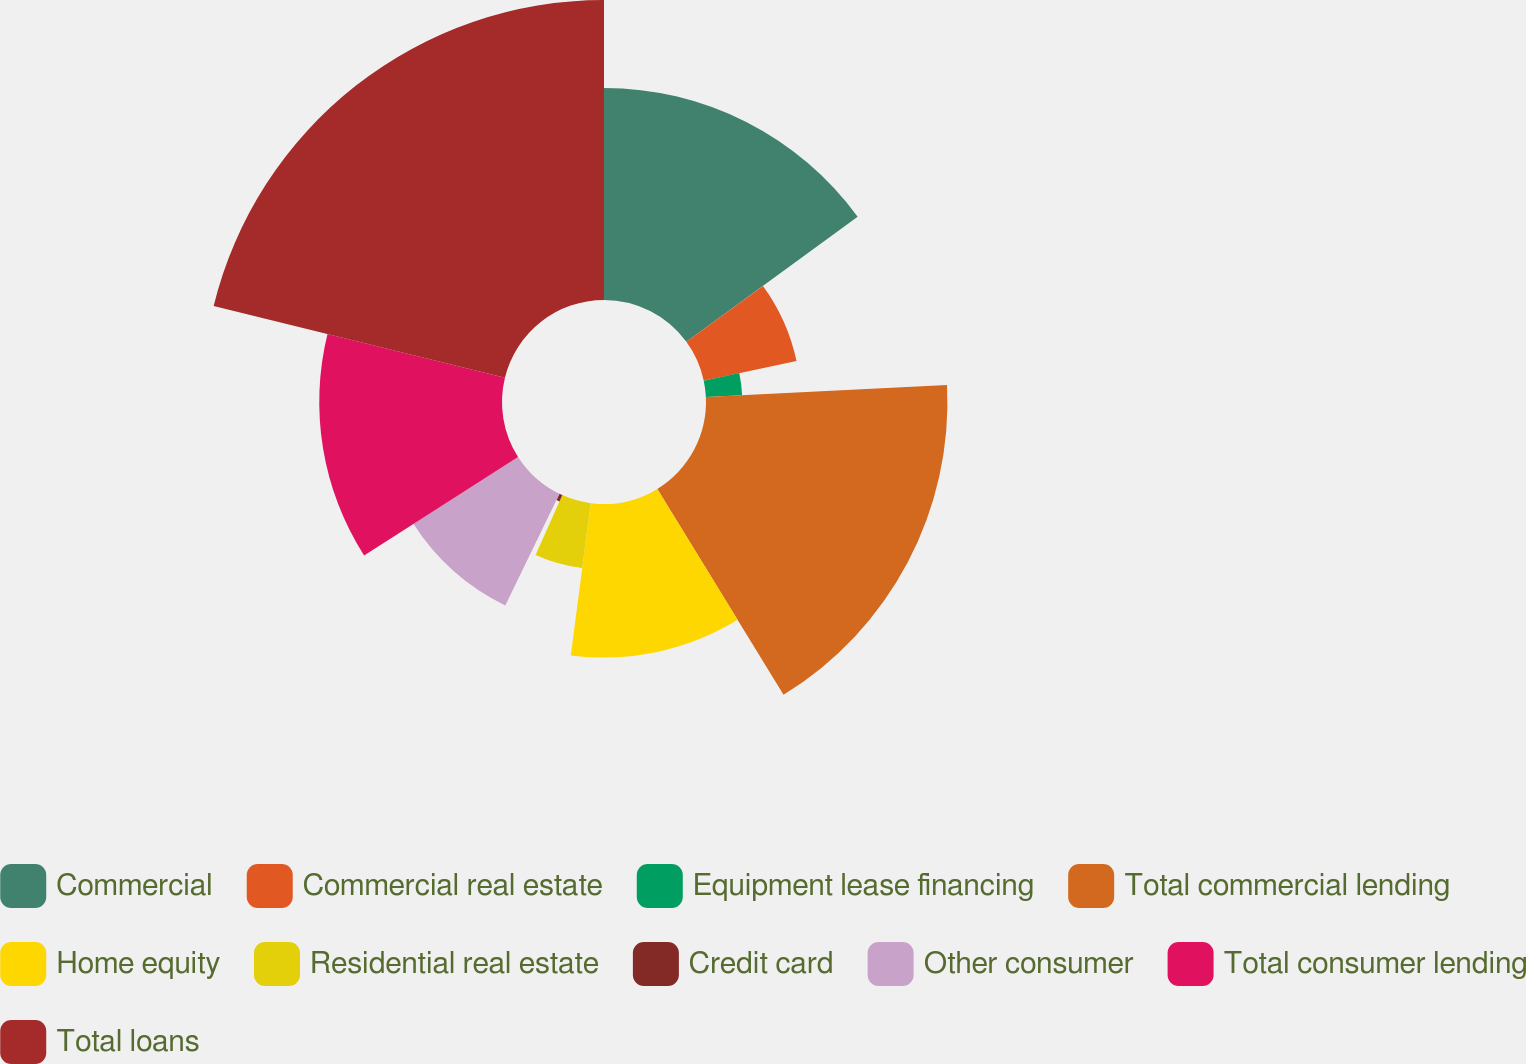Convert chart. <chart><loc_0><loc_0><loc_500><loc_500><pie_chart><fcel>Commercial<fcel>Commercial real estate<fcel>Equipment lease financing<fcel>Total commercial lending<fcel>Home equity<fcel>Residential real estate<fcel>Credit card<fcel>Other consumer<fcel>Total consumer lending<fcel>Total loans<nl><fcel>14.96%<fcel>6.69%<fcel>2.56%<fcel>17.03%<fcel>10.83%<fcel>4.62%<fcel>0.49%<fcel>8.76%<fcel>12.89%<fcel>21.16%<nl></chart> 